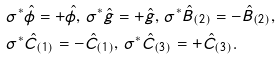<formula> <loc_0><loc_0><loc_500><loc_500>& \sigma ^ { \ast } \hat { \phi } = + \hat { \phi } , \, \sigma ^ { \ast } \hat { g } = + \hat { g } , \, \sigma ^ { \ast } \hat { B } _ { ( 2 ) } = - \hat { B } _ { ( 2 ) } , \\ & \sigma ^ { \ast } \hat { C } _ { ( 1 ) } = - \hat { C } _ { ( 1 ) } , \, \sigma ^ { \ast } \hat { C } _ { ( 3 ) } = + \hat { C } _ { ( 3 ) } .</formula> 